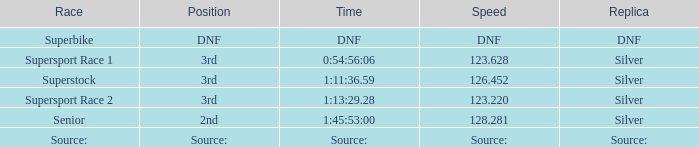Which position has a speed of 123.220? 3rd. 